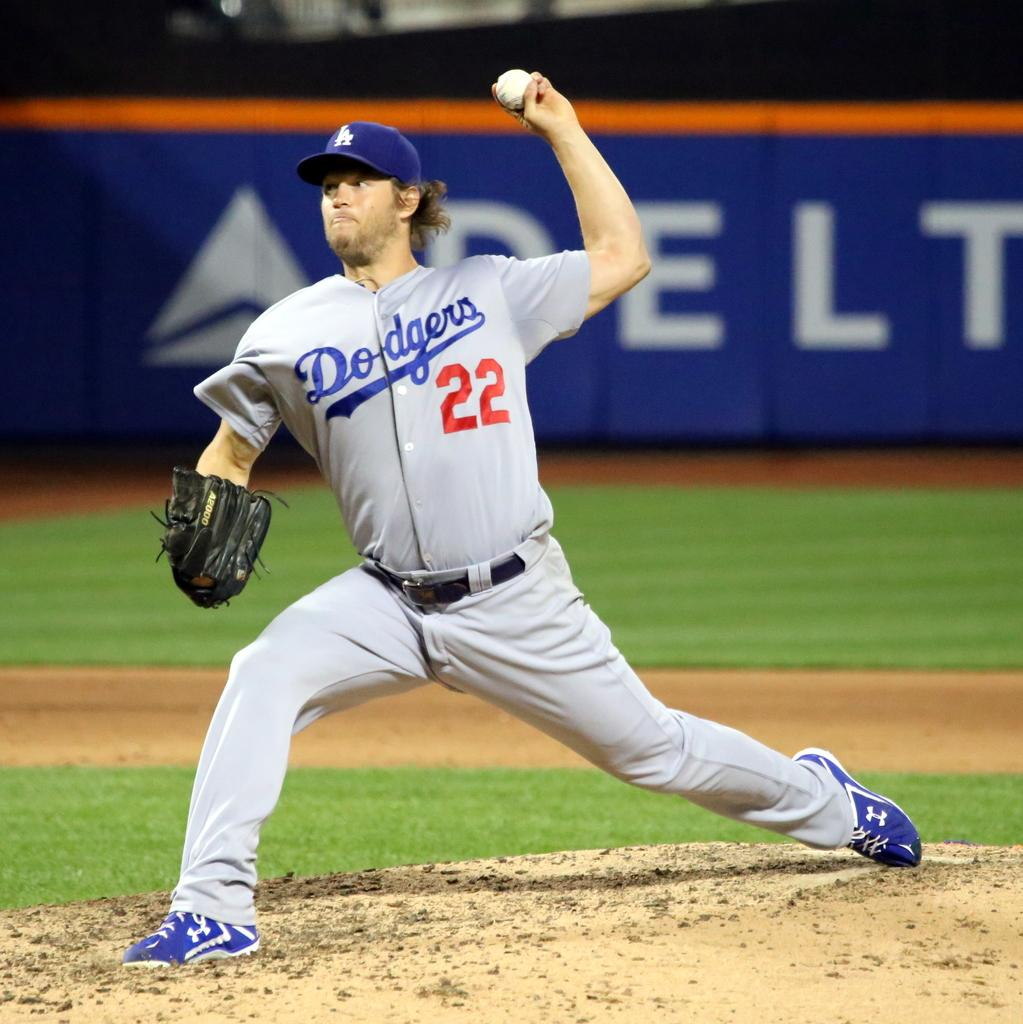<image>
Describe the image concisely. A sports player with a number 22 on his shirt. 